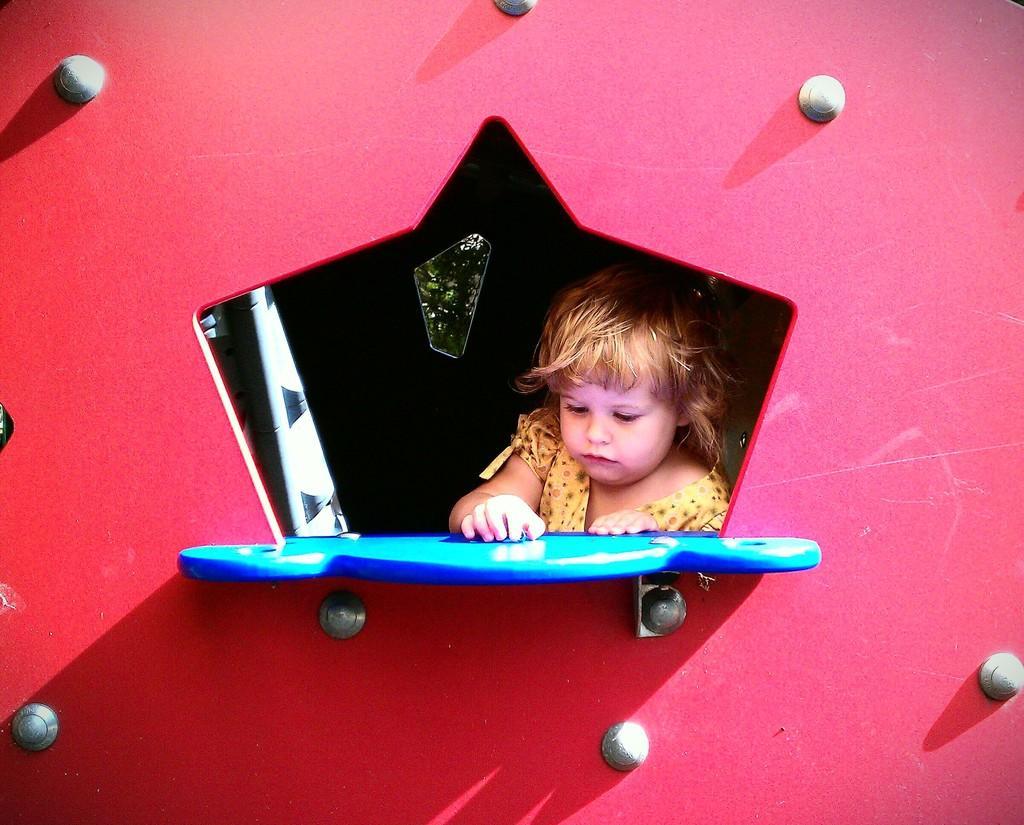How would you summarize this image in a sentence or two? In this image I can see colorful wall there are some screws attached to the wall , in the middle I can see a baby and board visible. 